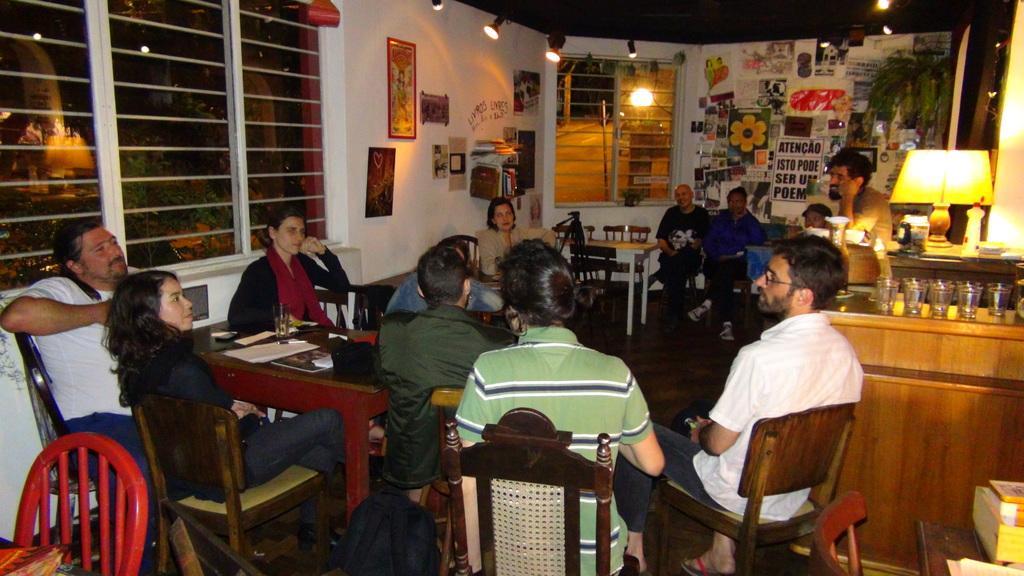How would you summarize this image in a sentence or two? In the image we can see that many people sitting on chair and there is a table in front of them. Here there are many photos stick to the wall. There is a lamp, glass and a plant. This is a light. 